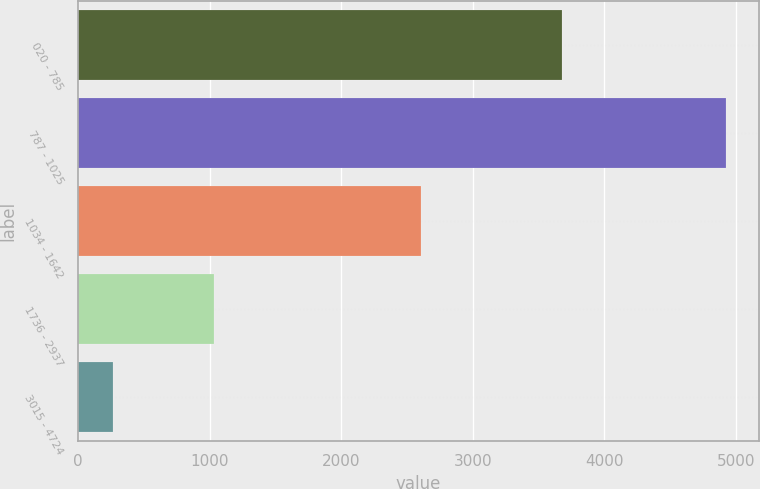Convert chart. <chart><loc_0><loc_0><loc_500><loc_500><bar_chart><fcel>020 - 785<fcel>787 - 1025<fcel>1034 - 1642<fcel>1736 - 2937<fcel>3015 - 4724<nl><fcel>3681<fcel>4928<fcel>2607<fcel>1033<fcel>265<nl></chart> 